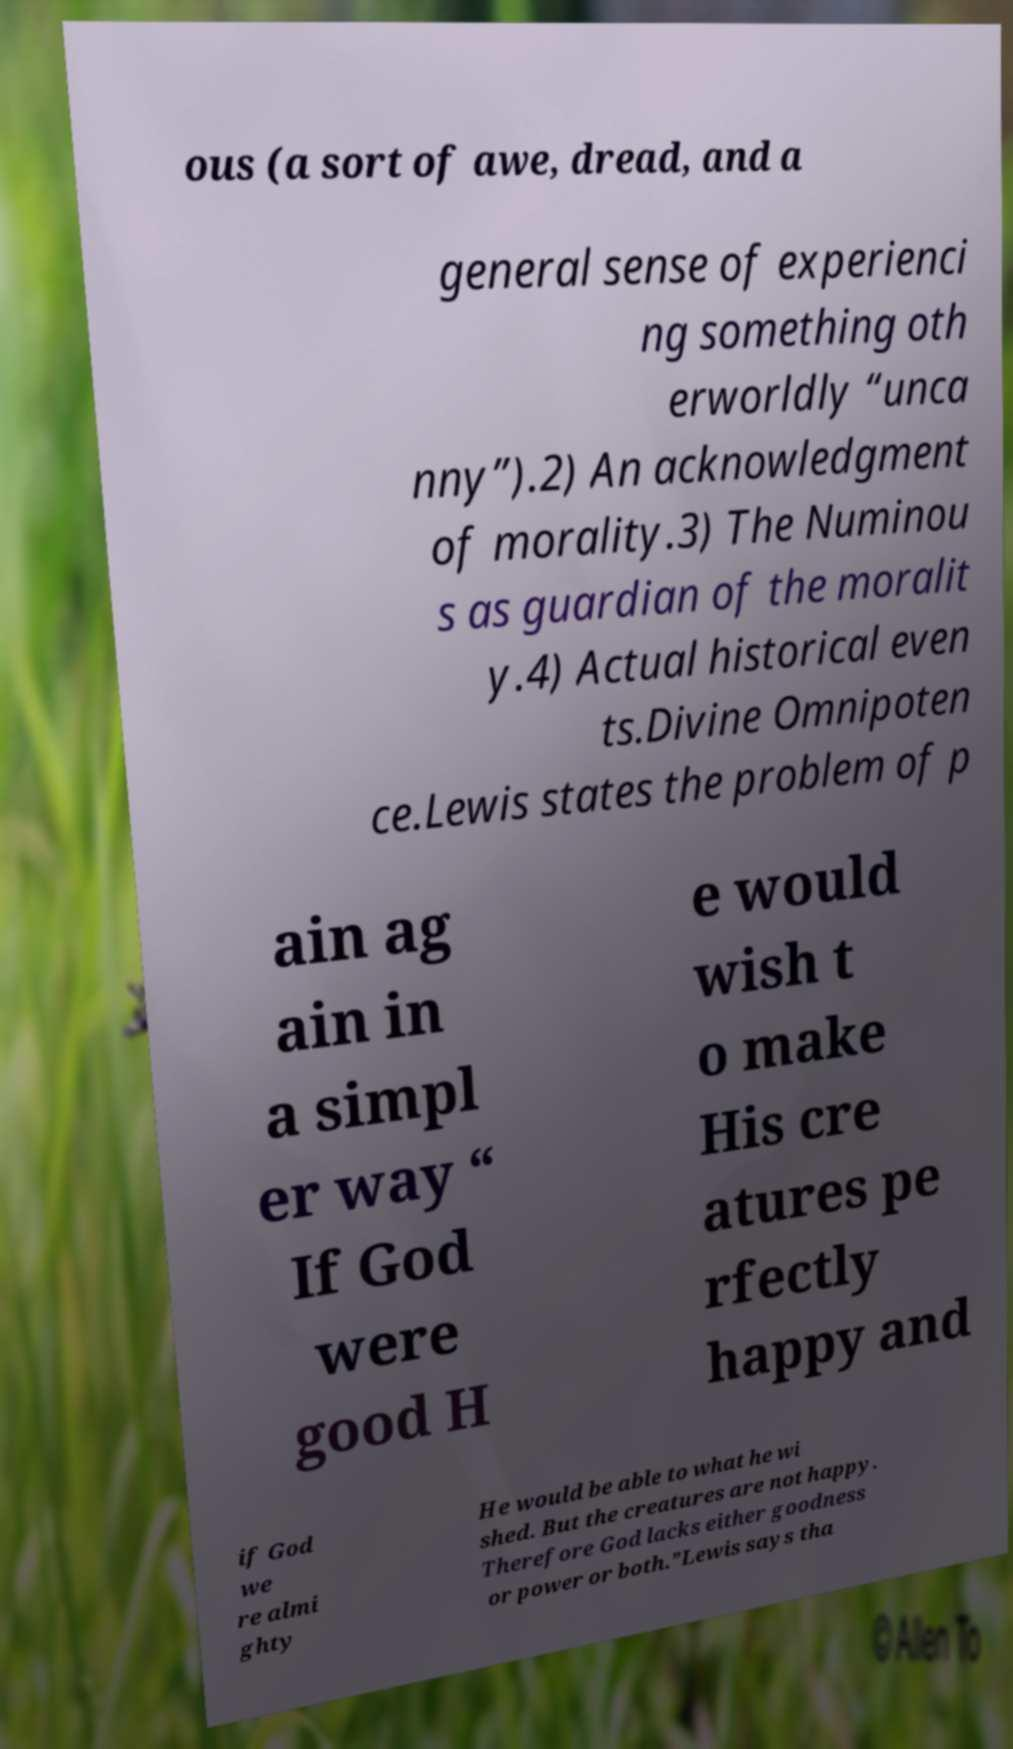There's text embedded in this image that I need extracted. Can you transcribe it verbatim? ous (a sort of awe, dread, and a general sense of experienci ng something oth erworldly “unca nny”).2) An acknowledgment of morality.3) The Numinou s as guardian of the moralit y.4) Actual historical even ts.Divine Omnipoten ce.Lewis states the problem of p ain ag ain in a simpl er way “ If God were good H e would wish t o make His cre atures pe rfectly happy and if God we re almi ghty He would be able to what he wi shed. But the creatures are not happy. Therefore God lacks either goodness or power or both.”Lewis says tha 